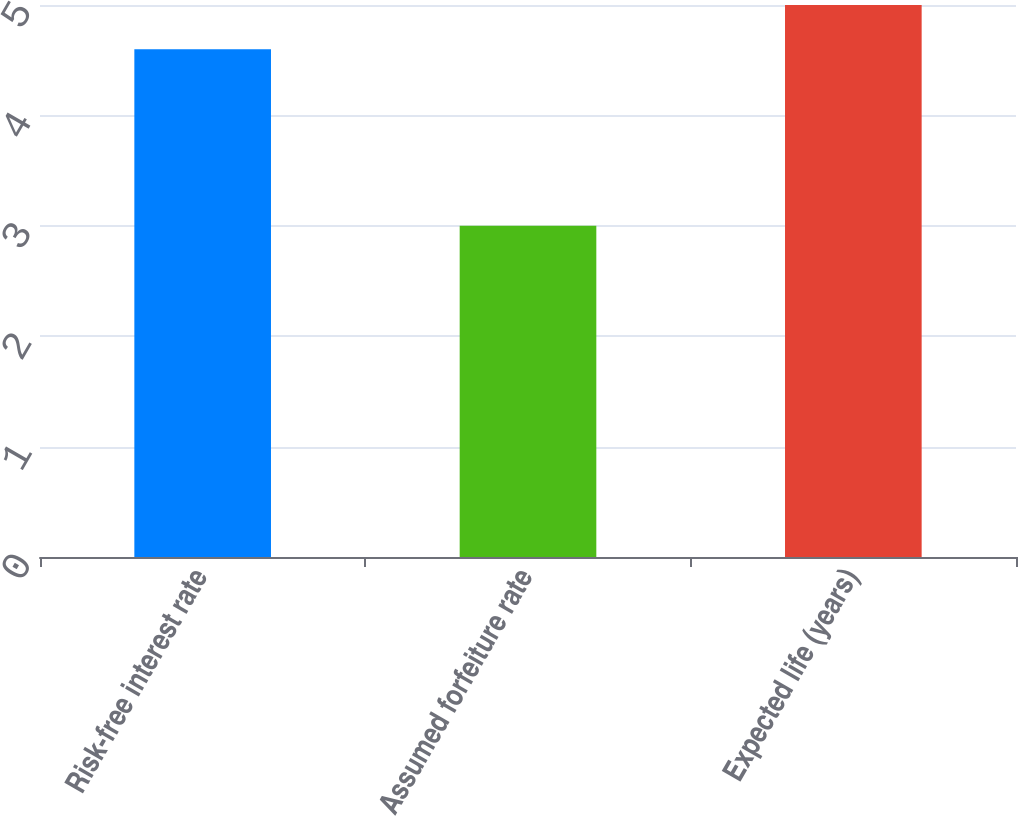Convert chart to OTSL. <chart><loc_0><loc_0><loc_500><loc_500><bar_chart><fcel>Risk-free interest rate<fcel>Assumed forfeiture rate<fcel>Expected life (years)<nl><fcel>4.6<fcel>3<fcel>5<nl></chart> 